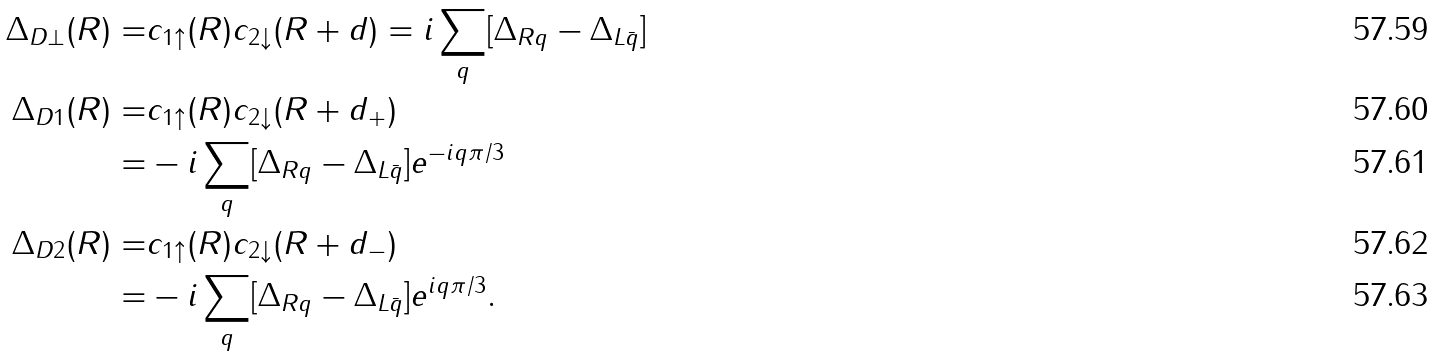<formula> <loc_0><loc_0><loc_500><loc_500>\Delta _ { D \perp } ( R ) = & c _ { 1 \uparrow } ( R ) c _ { 2 \downarrow } ( R + d ) = i \sum _ { q } [ \Delta _ { R q } - \Delta _ { L \bar { q } } ] \\ \Delta _ { D 1 } ( R ) = & c _ { 1 \uparrow } ( R ) c _ { 2 \downarrow } ( R + d _ { + } ) \\ = & - i \sum _ { q } [ \Delta _ { R q } - \Delta _ { L \bar { q } } ] e ^ { - i q \pi / 3 } \\ \Delta _ { D 2 } ( R ) = & c _ { 1 \uparrow } ( R ) c _ { 2 \downarrow } ( R + d _ { - } ) \\ = & - i \sum _ { q } [ \Delta _ { R q } - \Delta _ { L \bar { q } } ] e ^ { i q \pi / 3 } .</formula> 